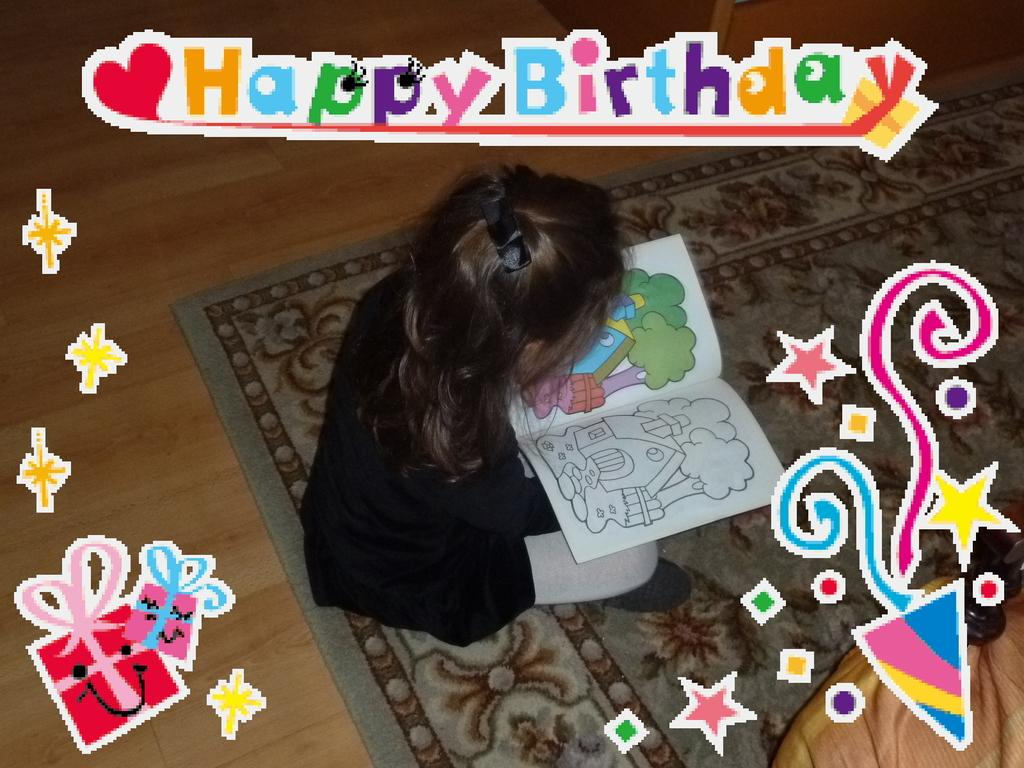Who is the main subject in the image? There is a girl in the image. What is the girl doing in the image? The girl is sitting on a carpet and holding a book. What is the color of the floor in the image? The floor is brown in color. What type of crime is the girl involved in within the image? There is no indication of any crime or trouble in the image; the girl is simply sitting on a carpet and holding a book. 